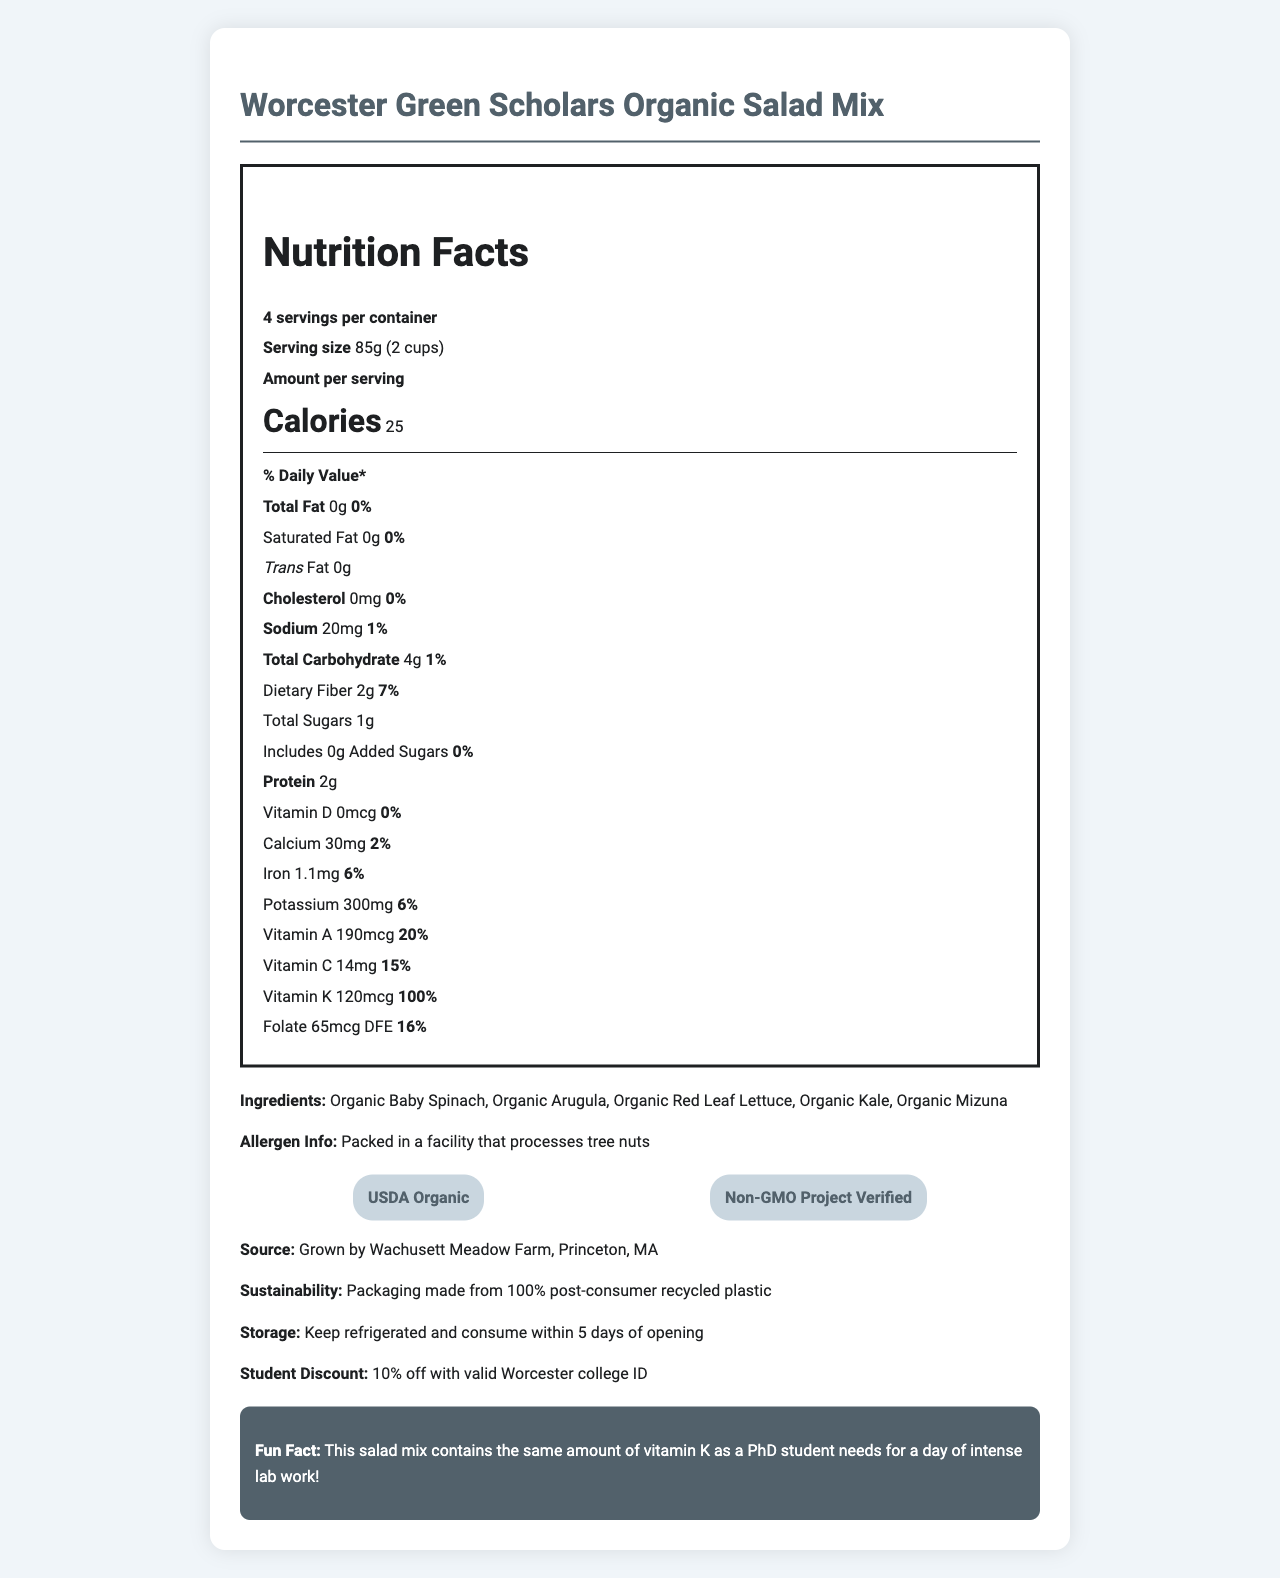what is the serving size? The serving size is listed on the document as "85g (2 cups)".
Answer: 85g (2 cups) how many servings are there per container? The document states there are "4 servings per container".
Answer: 4 what is the amount of dietary fiber per serving? The document lists dietary fiber as "2g" per serving.
Answer: 2g how much vitamin K is in one serving? According to the document, there is "120mcg" of vitamin K per serving.
Answer: 120mcg does this product contain any cholesterol? The document states that the cholesterol amount is "0mg", indicating that it contains no cholesterol.
Answer: No what percentage of the daily value of iron does one serving provide? The document lists the % daily value of iron as "6%".
Answer: 6% what are the main ingredients in the salad mix? The ingredients section lists these as the main ingredients.
Answer: Organic Baby Spinach, Organic Arugula, Organic Red Leaf Lettuce, Organic Kale, Organic Mizuna what certifications does this product have? A. USDA Organic, Non-GMO Project Verified B. Organic Certification, Halal Certification C. Kosher Certified, Gluten-Free D. FDA Approved, Whole30 The document lists "USDA Organic" and "Non-GMO Project Verified" as the certifications.
Answer: A which vitamin has the highest daily value percentage in the salad mix? i. Vitamin A ii. Vitamin C iii. Vitamin K iv. Vitamin D The document shows that Vitamin K has a 100% daily value percentage, which is the highest of all the vitamins listed.
Answer: iii is the packaging for this salad mix environmentally friendly? The document states, "Packaging made from 100% post-consumer recycled plastic," indicating it is environmentally friendly.
Answer: Yes summarize the key nutritional and product information for Worcester Green Scholars Organic Salad Mix. This summary includes the main nutritional highlights, organic ingredients, sustainability aspect, and certifications based on the information provided in the document.
Answer: The Worcester Green Scholars Organic Salad Mix offers a low-calorie, nutrient-rich option, with key vitamins such as Vitamin K (100% DV) and Vitamin A (20% DV). It's free of cholesterol and trans fats, has dietary fiber (7% DV), and contains organic ingredients like spinach, arugula, and kale. It's packed in sustainable packaging with USDA Organic and Non-GMO Project Verified certifications. who is the producer of the salad mix? The document provides the source as "Grown by Wachusett Meadow Farm, Princeton, MA".
Answer: Wachusett Meadow Farm, Princeton, MA how much total sugar is in a serving of the salad mix? The document lists "Total Sugars" as "1g".
Answer: 1g how much potassium does one serving provide? According to the document, one serving of the salad mix provides "300mg" of potassium.
Answer: 300mg does the salad mix contain any allergen information? The document mentions "Packed in a facility that processes tree nuts" as allergen information.
Answer: Yes what is the storage instruction for the salad mix? The document states to "Keep refrigerated and consume within 5 days of opening".
Answer: Keep refrigerated and consume within 5 days of opening how many grams of protein are in a serving of the salad mix? The document states there are "2g" of protein per serving.
Answer: 2g how does a student get a discount on this salad mix? A. Coupon Code B. 20% Off Every Purchase C. 10% off with valid Worcester college ID D. Refer a Friend The document states, "10% off with valid Worcester college ID".
Answer: C how much calcium does one serving provide? The document lists "Calcium" as "30mg".
Answer: 30mg where can I buy this salad mix? The document does not provide information on purchase locations, so the answer cannot be determined.
Answer: Cannot be determined 